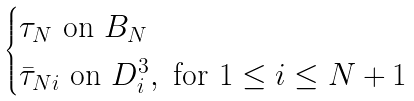<formula> <loc_0><loc_0><loc_500><loc_500>\begin{cases} \tau _ { N } \text { on } B _ { N } \\ \bar { \tau } _ { N i } \text { on } D ^ { 3 } _ { i } , \text { for } 1 \leq i \leq N + 1 \end{cases}</formula> 